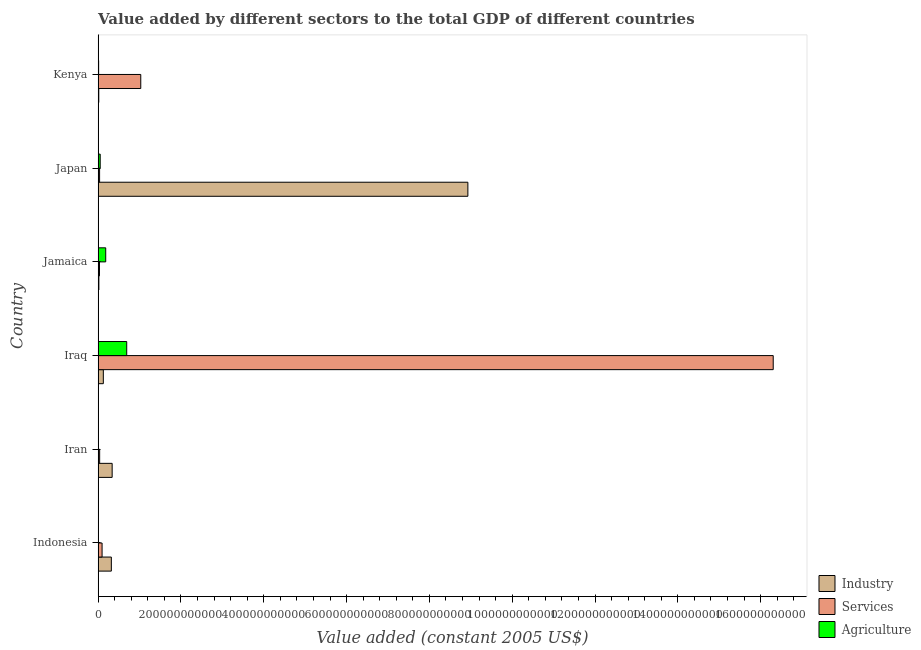How many different coloured bars are there?
Your answer should be compact. 3. Are the number of bars per tick equal to the number of legend labels?
Provide a short and direct response. Yes. How many bars are there on the 4th tick from the top?
Offer a terse response. 3. What is the label of the 2nd group of bars from the top?
Your answer should be compact. Japan. What is the value added by services in Iraq?
Your answer should be very brief. 1.63e+12. Across all countries, what is the maximum value added by services?
Make the answer very short. 1.63e+12. Across all countries, what is the minimum value added by agricultural sector?
Keep it short and to the point. 1.66e+08. In which country was the value added by services maximum?
Provide a succinct answer. Iraq. In which country was the value added by services minimum?
Your answer should be very brief. Jamaica. What is the total value added by industrial sector in the graph?
Give a very brief answer. 9.75e+11. What is the difference between the value added by agricultural sector in Indonesia and that in Jamaica?
Your answer should be very brief. -1.82e+1. What is the difference between the value added by industrial sector in Japan and the value added by agricultural sector in Iran?
Make the answer very short. 8.92e+11. What is the average value added by services per country?
Your response must be concise. 2.92e+11. What is the difference between the value added by services and value added by agricultural sector in Iran?
Your response must be concise. 3.07e+09. What is the ratio of the value added by agricultural sector in Japan to that in Kenya?
Your answer should be compact. 4.04. Is the value added by services in Iran less than that in Japan?
Offer a very short reply. No. What is the difference between the highest and the second highest value added by agricultural sector?
Offer a terse response. 5.07e+1. What is the difference between the highest and the lowest value added by services?
Provide a short and direct response. 1.63e+12. What does the 2nd bar from the top in Jamaica represents?
Provide a short and direct response. Services. What does the 1st bar from the bottom in Indonesia represents?
Keep it short and to the point. Industry. Is it the case that in every country, the sum of the value added by industrial sector and value added by services is greater than the value added by agricultural sector?
Your answer should be compact. No. How many countries are there in the graph?
Provide a succinct answer. 6. What is the difference between two consecutive major ticks on the X-axis?
Your answer should be very brief. 2.00e+11. Are the values on the major ticks of X-axis written in scientific E-notation?
Your answer should be compact. No. Does the graph contain grids?
Provide a succinct answer. No. Where does the legend appear in the graph?
Your answer should be very brief. Bottom right. How are the legend labels stacked?
Offer a very short reply. Vertical. What is the title of the graph?
Offer a very short reply. Value added by different sectors to the total GDP of different countries. What is the label or title of the X-axis?
Your answer should be very brief. Value added (constant 2005 US$). What is the Value added (constant 2005 US$) in Industry in Indonesia?
Give a very brief answer. 3.20e+1. What is the Value added (constant 2005 US$) in Services in Indonesia?
Make the answer very short. 9.55e+09. What is the Value added (constant 2005 US$) in Agriculture in Indonesia?
Your answer should be compact. 1.66e+08. What is the Value added (constant 2005 US$) of Industry in Iran?
Your answer should be compact. 3.39e+1. What is the Value added (constant 2005 US$) of Services in Iran?
Provide a short and direct response. 3.70e+09. What is the Value added (constant 2005 US$) in Agriculture in Iran?
Keep it short and to the point. 6.29e+08. What is the Value added (constant 2005 US$) in Industry in Iraq?
Your response must be concise. 1.26e+1. What is the Value added (constant 2005 US$) of Services in Iraq?
Your response must be concise. 1.63e+12. What is the Value added (constant 2005 US$) of Agriculture in Iraq?
Provide a succinct answer. 6.91e+1. What is the Value added (constant 2005 US$) of Industry in Jamaica?
Give a very brief answer. 1.84e+09. What is the Value added (constant 2005 US$) of Services in Jamaica?
Your response must be concise. 3.31e+09. What is the Value added (constant 2005 US$) in Agriculture in Jamaica?
Ensure brevity in your answer.  1.84e+1. What is the Value added (constant 2005 US$) of Industry in Japan?
Provide a succinct answer. 8.93e+11. What is the Value added (constant 2005 US$) in Services in Japan?
Keep it short and to the point. 3.56e+09. What is the Value added (constant 2005 US$) in Agriculture in Japan?
Offer a terse response. 5.04e+09. What is the Value added (constant 2005 US$) in Industry in Kenya?
Ensure brevity in your answer.  1.60e+09. What is the Value added (constant 2005 US$) of Services in Kenya?
Give a very brief answer. 1.03e+11. What is the Value added (constant 2005 US$) in Agriculture in Kenya?
Your answer should be compact. 1.25e+09. Across all countries, what is the maximum Value added (constant 2005 US$) in Industry?
Your response must be concise. 8.93e+11. Across all countries, what is the maximum Value added (constant 2005 US$) in Services?
Make the answer very short. 1.63e+12. Across all countries, what is the maximum Value added (constant 2005 US$) of Agriculture?
Offer a terse response. 6.91e+1. Across all countries, what is the minimum Value added (constant 2005 US$) of Industry?
Provide a short and direct response. 1.60e+09. Across all countries, what is the minimum Value added (constant 2005 US$) of Services?
Give a very brief answer. 3.31e+09. Across all countries, what is the minimum Value added (constant 2005 US$) in Agriculture?
Your response must be concise. 1.66e+08. What is the total Value added (constant 2005 US$) in Industry in the graph?
Your response must be concise. 9.75e+11. What is the total Value added (constant 2005 US$) in Services in the graph?
Make the answer very short. 1.75e+12. What is the total Value added (constant 2005 US$) of Agriculture in the graph?
Provide a succinct answer. 9.45e+1. What is the difference between the Value added (constant 2005 US$) of Industry in Indonesia and that in Iran?
Offer a terse response. -1.95e+09. What is the difference between the Value added (constant 2005 US$) in Services in Indonesia and that in Iran?
Make the answer very short. 5.85e+09. What is the difference between the Value added (constant 2005 US$) in Agriculture in Indonesia and that in Iran?
Make the answer very short. -4.63e+08. What is the difference between the Value added (constant 2005 US$) in Industry in Indonesia and that in Iraq?
Your answer should be very brief. 1.94e+1. What is the difference between the Value added (constant 2005 US$) of Services in Indonesia and that in Iraq?
Your answer should be very brief. -1.62e+12. What is the difference between the Value added (constant 2005 US$) in Agriculture in Indonesia and that in Iraq?
Your response must be concise. -6.89e+1. What is the difference between the Value added (constant 2005 US$) of Industry in Indonesia and that in Jamaica?
Your response must be concise. 3.01e+1. What is the difference between the Value added (constant 2005 US$) of Services in Indonesia and that in Jamaica?
Provide a succinct answer. 6.24e+09. What is the difference between the Value added (constant 2005 US$) of Agriculture in Indonesia and that in Jamaica?
Provide a short and direct response. -1.82e+1. What is the difference between the Value added (constant 2005 US$) of Industry in Indonesia and that in Japan?
Make the answer very short. -8.61e+11. What is the difference between the Value added (constant 2005 US$) of Services in Indonesia and that in Japan?
Keep it short and to the point. 5.99e+09. What is the difference between the Value added (constant 2005 US$) in Agriculture in Indonesia and that in Japan?
Keep it short and to the point. -4.87e+09. What is the difference between the Value added (constant 2005 US$) of Industry in Indonesia and that in Kenya?
Offer a very short reply. 3.04e+1. What is the difference between the Value added (constant 2005 US$) in Services in Indonesia and that in Kenya?
Keep it short and to the point. -9.34e+1. What is the difference between the Value added (constant 2005 US$) in Agriculture in Indonesia and that in Kenya?
Offer a very short reply. -1.08e+09. What is the difference between the Value added (constant 2005 US$) in Industry in Iran and that in Iraq?
Offer a terse response. 2.13e+1. What is the difference between the Value added (constant 2005 US$) in Services in Iran and that in Iraq?
Provide a succinct answer. -1.63e+12. What is the difference between the Value added (constant 2005 US$) of Agriculture in Iran and that in Iraq?
Keep it short and to the point. -6.84e+1. What is the difference between the Value added (constant 2005 US$) in Industry in Iran and that in Jamaica?
Keep it short and to the point. 3.21e+1. What is the difference between the Value added (constant 2005 US$) of Services in Iran and that in Jamaica?
Ensure brevity in your answer.  3.91e+08. What is the difference between the Value added (constant 2005 US$) of Agriculture in Iran and that in Jamaica?
Offer a very short reply. -1.77e+1. What is the difference between the Value added (constant 2005 US$) of Industry in Iran and that in Japan?
Keep it short and to the point. -8.59e+11. What is the difference between the Value added (constant 2005 US$) in Services in Iran and that in Japan?
Offer a very short reply. 1.42e+08. What is the difference between the Value added (constant 2005 US$) in Agriculture in Iran and that in Japan?
Offer a very short reply. -4.41e+09. What is the difference between the Value added (constant 2005 US$) in Industry in Iran and that in Kenya?
Give a very brief answer. 3.23e+1. What is the difference between the Value added (constant 2005 US$) in Services in Iran and that in Kenya?
Give a very brief answer. -9.93e+1. What is the difference between the Value added (constant 2005 US$) of Agriculture in Iran and that in Kenya?
Provide a short and direct response. -6.16e+08. What is the difference between the Value added (constant 2005 US$) in Industry in Iraq and that in Jamaica?
Provide a succinct answer. 1.08e+1. What is the difference between the Value added (constant 2005 US$) in Services in Iraq and that in Jamaica?
Your answer should be very brief. 1.63e+12. What is the difference between the Value added (constant 2005 US$) in Agriculture in Iraq and that in Jamaica?
Provide a short and direct response. 5.07e+1. What is the difference between the Value added (constant 2005 US$) of Industry in Iraq and that in Japan?
Provide a short and direct response. -8.80e+11. What is the difference between the Value added (constant 2005 US$) in Services in Iraq and that in Japan?
Give a very brief answer. 1.63e+12. What is the difference between the Value added (constant 2005 US$) of Agriculture in Iraq and that in Japan?
Ensure brevity in your answer.  6.40e+1. What is the difference between the Value added (constant 2005 US$) in Industry in Iraq and that in Kenya?
Offer a terse response. 1.10e+1. What is the difference between the Value added (constant 2005 US$) of Services in Iraq and that in Kenya?
Offer a terse response. 1.53e+12. What is the difference between the Value added (constant 2005 US$) in Agriculture in Iraq and that in Kenya?
Provide a short and direct response. 6.78e+1. What is the difference between the Value added (constant 2005 US$) in Industry in Jamaica and that in Japan?
Give a very brief answer. -8.91e+11. What is the difference between the Value added (constant 2005 US$) in Services in Jamaica and that in Japan?
Provide a short and direct response. -2.48e+08. What is the difference between the Value added (constant 2005 US$) of Agriculture in Jamaica and that in Japan?
Offer a terse response. 1.33e+1. What is the difference between the Value added (constant 2005 US$) in Industry in Jamaica and that in Kenya?
Ensure brevity in your answer.  2.39e+08. What is the difference between the Value added (constant 2005 US$) in Services in Jamaica and that in Kenya?
Your response must be concise. -9.97e+1. What is the difference between the Value added (constant 2005 US$) in Agriculture in Jamaica and that in Kenya?
Your answer should be compact. 1.71e+1. What is the difference between the Value added (constant 2005 US$) in Industry in Japan and that in Kenya?
Your answer should be compact. 8.91e+11. What is the difference between the Value added (constant 2005 US$) in Services in Japan and that in Kenya?
Ensure brevity in your answer.  -9.94e+1. What is the difference between the Value added (constant 2005 US$) of Agriculture in Japan and that in Kenya?
Your response must be concise. 3.79e+09. What is the difference between the Value added (constant 2005 US$) of Industry in Indonesia and the Value added (constant 2005 US$) of Services in Iran?
Ensure brevity in your answer.  2.82e+1. What is the difference between the Value added (constant 2005 US$) of Industry in Indonesia and the Value added (constant 2005 US$) of Agriculture in Iran?
Your answer should be very brief. 3.13e+1. What is the difference between the Value added (constant 2005 US$) in Services in Indonesia and the Value added (constant 2005 US$) in Agriculture in Iran?
Offer a terse response. 8.92e+09. What is the difference between the Value added (constant 2005 US$) in Industry in Indonesia and the Value added (constant 2005 US$) in Services in Iraq?
Your answer should be very brief. -1.60e+12. What is the difference between the Value added (constant 2005 US$) of Industry in Indonesia and the Value added (constant 2005 US$) of Agriculture in Iraq?
Your response must be concise. -3.71e+1. What is the difference between the Value added (constant 2005 US$) of Services in Indonesia and the Value added (constant 2005 US$) of Agriculture in Iraq?
Provide a succinct answer. -5.95e+1. What is the difference between the Value added (constant 2005 US$) in Industry in Indonesia and the Value added (constant 2005 US$) in Services in Jamaica?
Offer a terse response. 2.86e+1. What is the difference between the Value added (constant 2005 US$) of Industry in Indonesia and the Value added (constant 2005 US$) of Agriculture in Jamaica?
Your answer should be very brief. 1.36e+1. What is the difference between the Value added (constant 2005 US$) of Services in Indonesia and the Value added (constant 2005 US$) of Agriculture in Jamaica?
Offer a very short reply. -8.81e+09. What is the difference between the Value added (constant 2005 US$) in Industry in Indonesia and the Value added (constant 2005 US$) in Services in Japan?
Keep it short and to the point. 2.84e+1. What is the difference between the Value added (constant 2005 US$) of Industry in Indonesia and the Value added (constant 2005 US$) of Agriculture in Japan?
Keep it short and to the point. 2.69e+1. What is the difference between the Value added (constant 2005 US$) in Services in Indonesia and the Value added (constant 2005 US$) in Agriculture in Japan?
Keep it short and to the point. 4.52e+09. What is the difference between the Value added (constant 2005 US$) in Industry in Indonesia and the Value added (constant 2005 US$) in Services in Kenya?
Provide a short and direct response. -7.10e+1. What is the difference between the Value added (constant 2005 US$) of Industry in Indonesia and the Value added (constant 2005 US$) of Agriculture in Kenya?
Offer a terse response. 3.07e+1. What is the difference between the Value added (constant 2005 US$) in Services in Indonesia and the Value added (constant 2005 US$) in Agriculture in Kenya?
Offer a very short reply. 8.31e+09. What is the difference between the Value added (constant 2005 US$) in Industry in Iran and the Value added (constant 2005 US$) in Services in Iraq?
Your response must be concise. -1.60e+12. What is the difference between the Value added (constant 2005 US$) in Industry in Iran and the Value added (constant 2005 US$) in Agriculture in Iraq?
Give a very brief answer. -3.52e+1. What is the difference between the Value added (constant 2005 US$) of Services in Iran and the Value added (constant 2005 US$) of Agriculture in Iraq?
Make the answer very short. -6.54e+1. What is the difference between the Value added (constant 2005 US$) of Industry in Iran and the Value added (constant 2005 US$) of Services in Jamaica?
Provide a short and direct response. 3.06e+1. What is the difference between the Value added (constant 2005 US$) in Industry in Iran and the Value added (constant 2005 US$) in Agriculture in Jamaica?
Offer a very short reply. 1.55e+1. What is the difference between the Value added (constant 2005 US$) in Services in Iran and the Value added (constant 2005 US$) in Agriculture in Jamaica?
Keep it short and to the point. -1.47e+1. What is the difference between the Value added (constant 2005 US$) of Industry in Iran and the Value added (constant 2005 US$) of Services in Japan?
Your answer should be very brief. 3.03e+1. What is the difference between the Value added (constant 2005 US$) in Industry in Iran and the Value added (constant 2005 US$) in Agriculture in Japan?
Ensure brevity in your answer.  2.89e+1. What is the difference between the Value added (constant 2005 US$) of Services in Iran and the Value added (constant 2005 US$) of Agriculture in Japan?
Give a very brief answer. -1.33e+09. What is the difference between the Value added (constant 2005 US$) in Industry in Iran and the Value added (constant 2005 US$) in Services in Kenya?
Make the answer very short. -6.91e+1. What is the difference between the Value added (constant 2005 US$) in Industry in Iran and the Value added (constant 2005 US$) in Agriculture in Kenya?
Offer a terse response. 3.27e+1. What is the difference between the Value added (constant 2005 US$) in Services in Iran and the Value added (constant 2005 US$) in Agriculture in Kenya?
Your answer should be very brief. 2.46e+09. What is the difference between the Value added (constant 2005 US$) in Industry in Iraq and the Value added (constant 2005 US$) in Services in Jamaica?
Provide a succinct answer. 9.29e+09. What is the difference between the Value added (constant 2005 US$) of Industry in Iraq and the Value added (constant 2005 US$) of Agriculture in Jamaica?
Give a very brief answer. -5.76e+09. What is the difference between the Value added (constant 2005 US$) of Services in Iraq and the Value added (constant 2005 US$) of Agriculture in Jamaica?
Your answer should be compact. 1.61e+12. What is the difference between the Value added (constant 2005 US$) in Industry in Iraq and the Value added (constant 2005 US$) in Services in Japan?
Make the answer very short. 9.04e+09. What is the difference between the Value added (constant 2005 US$) of Industry in Iraq and the Value added (constant 2005 US$) of Agriculture in Japan?
Make the answer very short. 7.56e+09. What is the difference between the Value added (constant 2005 US$) in Services in Iraq and the Value added (constant 2005 US$) in Agriculture in Japan?
Make the answer very short. 1.63e+12. What is the difference between the Value added (constant 2005 US$) of Industry in Iraq and the Value added (constant 2005 US$) of Services in Kenya?
Your answer should be very brief. -9.04e+1. What is the difference between the Value added (constant 2005 US$) in Industry in Iraq and the Value added (constant 2005 US$) in Agriculture in Kenya?
Give a very brief answer. 1.14e+1. What is the difference between the Value added (constant 2005 US$) of Services in Iraq and the Value added (constant 2005 US$) of Agriculture in Kenya?
Keep it short and to the point. 1.63e+12. What is the difference between the Value added (constant 2005 US$) in Industry in Jamaica and the Value added (constant 2005 US$) in Services in Japan?
Your response must be concise. -1.72e+09. What is the difference between the Value added (constant 2005 US$) of Industry in Jamaica and the Value added (constant 2005 US$) of Agriculture in Japan?
Provide a succinct answer. -3.20e+09. What is the difference between the Value added (constant 2005 US$) of Services in Jamaica and the Value added (constant 2005 US$) of Agriculture in Japan?
Make the answer very short. -1.72e+09. What is the difference between the Value added (constant 2005 US$) in Industry in Jamaica and the Value added (constant 2005 US$) in Services in Kenya?
Your response must be concise. -1.01e+11. What is the difference between the Value added (constant 2005 US$) in Industry in Jamaica and the Value added (constant 2005 US$) in Agriculture in Kenya?
Make the answer very short. 5.90e+08. What is the difference between the Value added (constant 2005 US$) of Services in Jamaica and the Value added (constant 2005 US$) of Agriculture in Kenya?
Make the answer very short. 2.07e+09. What is the difference between the Value added (constant 2005 US$) in Industry in Japan and the Value added (constant 2005 US$) in Services in Kenya?
Ensure brevity in your answer.  7.90e+11. What is the difference between the Value added (constant 2005 US$) of Industry in Japan and the Value added (constant 2005 US$) of Agriculture in Kenya?
Ensure brevity in your answer.  8.92e+11. What is the difference between the Value added (constant 2005 US$) in Services in Japan and the Value added (constant 2005 US$) in Agriculture in Kenya?
Your answer should be compact. 2.31e+09. What is the average Value added (constant 2005 US$) of Industry per country?
Make the answer very short. 1.62e+11. What is the average Value added (constant 2005 US$) of Services per country?
Offer a very short reply. 2.92e+11. What is the average Value added (constant 2005 US$) of Agriculture per country?
Your answer should be compact. 1.58e+1. What is the difference between the Value added (constant 2005 US$) of Industry and Value added (constant 2005 US$) of Services in Indonesia?
Make the answer very short. 2.24e+1. What is the difference between the Value added (constant 2005 US$) of Industry and Value added (constant 2005 US$) of Agriculture in Indonesia?
Make the answer very short. 3.18e+1. What is the difference between the Value added (constant 2005 US$) of Services and Value added (constant 2005 US$) of Agriculture in Indonesia?
Provide a succinct answer. 9.39e+09. What is the difference between the Value added (constant 2005 US$) of Industry and Value added (constant 2005 US$) of Services in Iran?
Offer a terse response. 3.02e+1. What is the difference between the Value added (constant 2005 US$) in Industry and Value added (constant 2005 US$) in Agriculture in Iran?
Provide a short and direct response. 3.33e+1. What is the difference between the Value added (constant 2005 US$) in Services and Value added (constant 2005 US$) in Agriculture in Iran?
Your answer should be very brief. 3.07e+09. What is the difference between the Value added (constant 2005 US$) in Industry and Value added (constant 2005 US$) in Services in Iraq?
Ensure brevity in your answer.  -1.62e+12. What is the difference between the Value added (constant 2005 US$) in Industry and Value added (constant 2005 US$) in Agriculture in Iraq?
Your answer should be very brief. -5.65e+1. What is the difference between the Value added (constant 2005 US$) of Services and Value added (constant 2005 US$) of Agriculture in Iraq?
Your response must be concise. 1.56e+12. What is the difference between the Value added (constant 2005 US$) in Industry and Value added (constant 2005 US$) in Services in Jamaica?
Offer a very short reply. -1.48e+09. What is the difference between the Value added (constant 2005 US$) of Industry and Value added (constant 2005 US$) of Agriculture in Jamaica?
Make the answer very short. -1.65e+1. What is the difference between the Value added (constant 2005 US$) of Services and Value added (constant 2005 US$) of Agriculture in Jamaica?
Offer a terse response. -1.51e+1. What is the difference between the Value added (constant 2005 US$) in Industry and Value added (constant 2005 US$) in Services in Japan?
Your answer should be very brief. 8.89e+11. What is the difference between the Value added (constant 2005 US$) in Industry and Value added (constant 2005 US$) in Agriculture in Japan?
Provide a succinct answer. 8.88e+11. What is the difference between the Value added (constant 2005 US$) in Services and Value added (constant 2005 US$) in Agriculture in Japan?
Your response must be concise. -1.47e+09. What is the difference between the Value added (constant 2005 US$) of Industry and Value added (constant 2005 US$) of Services in Kenya?
Your answer should be very brief. -1.01e+11. What is the difference between the Value added (constant 2005 US$) of Industry and Value added (constant 2005 US$) of Agriculture in Kenya?
Ensure brevity in your answer.  3.51e+08. What is the difference between the Value added (constant 2005 US$) of Services and Value added (constant 2005 US$) of Agriculture in Kenya?
Make the answer very short. 1.02e+11. What is the ratio of the Value added (constant 2005 US$) in Industry in Indonesia to that in Iran?
Your answer should be very brief. 0.94. What is the ratio of the Value added (constant 2005 US$) of Services in Indonesia to that in Iran?
Your response must be concise. 2.58. What is the ratio of the Value added (constant 2005 US$) in Agriculture in Indonesia to that in Iran?
Give a very brief answer. 0.26. What is the ratio of the Value added (constant 2005 US$) in Industry in Indonesia to that in Iraq?
Make the answer very short. 2.54. What is the ratio of the Value added (constant 2005 US$) of Services in Indonesia to that in Iraq?
Your response must be concise. 0.01. What is the ratio of the Value added (constant 2005 US$) in Agriculture in Indonesia to that in Iraq?
Provide a short and direct response. 0. What is the ratio of the Value added (constant 2005 US$) of Industry in Indonesia to that in Jamaica?
Offer a very short reply. 17.4. What is the ratio of the Value added (constant 2005 US$) of Services in Indonesia to that in Jamaica?
Make the answer very short. 2.88. What is the ratio of the Value added (constant 2005 US$) of Agriculture in Indonesia to that in Jamaica?
Keep it short and to the point. 0.01. What is the ratio of the Value added (constant 2005 US$) of Industry in Indonesia to that in Japan?
Your answer should be very brief. 0.04. What is the ratio of the Value added (constant 2005 US$) in Services in Indonesia to that in Japan?
Ensure brevity in your answer.  2.68. What is the ratio of the Value added (constant 2005 US$) in Agriculture in Indonesia to that in Japan?
Keep it short and to the point. 0.03. What is the ratio of the Value added (constant 2005 US$) of Industry in Indonesia to that in Kenya?
Make the answer very short. 20.01. What is the ratio of the Value added (constant 2005 US$) in Services in Indonesia to that in Kenya?
Make the answer very short. 0.09. What is the ratio of the Value added (constant 2005 US$) in Agriculture in Indonesia to that in Kenya?
Offer a terse response. 0.13. What is the ratio of the Value added (constant 2005 US$) in Industry in Iran to that in Iraq?
Give a very brief answer. 2.69. What is the ratio of the Value added (constant 2005 US$) of Services in Iran to that in Iraq?
Provide a succinct answer. 0. What is the ratio of the Value added (constant 2005 US$) of Agriculture in Iran to that in Iraq?
Offer a terse response. 0.01. What is the ratio of the Value added (constant 2005 US$) in Industry in Iran to that in Jamaica?
Provide a short and direct response. 18.47. What is the ratio of the Value added (constant 2005 US$) of Services in Iran to that in Jamaica?
Keep it short and to the point. 1.12. What is the ratio of the Value added (constant 2005 US$) in Agriculture in Iran to that in Jamaica?
Ensure brevity in your answer.  0.03. What is the ratio of the Value added (constant 2005 US$) in Industry in Iran to that in Japan?
Give a very brief answer. 0.04. What is the ratio of the Value added (constant 2005 US$) in Services in Iran to that in Japan?
Provide a short and direct response. 1.04. What is the ratio of the Value added (constant 2005 US$) in Agriculture in Iran to that in Japan?
Provide a short and direct response. 0.12. What is the ratio of the Value added (constant 2005 US$) of Industry in Iran to that in Kenya?
Keep it short and to the point. 21.23. What is the ratio of the Value added (constant 2005 US$) of Services in Iran to that in Kenya?
Your response must be concise. 0.04. What is the ratio of the Value added (constant 2005 US$) in Agriculture in Iran to that in Kenya?
Your response must be concise. 0.51. What is the ratio of the Value added (constant 2005 US$) of Industry in Iraq to that in Jamaica?
Keep it short and to the point. 6.86. What is the ratio of the Value added (constant 2005 US$) of Services in Iraq to that in Jamaica?
Your answer should be compact. 492.26. What is the ratio of the Value added (constant 2005 US$) in Agriculture in Iraq to that in Jamaica?
Your answer should be very brief. 3.76. What is the ratio of the Value added (constant 2005 US$) of Industry in Iraq to that in Japan?
Provide a short and direct response. 0.01. What is the ratio of the Value added (constant 2005 US$) of Services in Iraq to that in Japan?
Your answer should be compact. 457.93. What is the ratio of the Value added (constant 2005 US$) of Agriculture in Iraq to that in Japan?
Provide a succinct answer. 13.72. What is the ratio of the Value added (constant 2005 US$) of Industry in Iraq to that in Kenya?
Your answer should be compact. 7.89. What is the ratio of the Value added (constant 2005 US$) of Services in Iraq to that in Kenya?
Ensure brevity in your answer.  15.83. What is the ratio of the Value added (constant 2005 US$) in Agriculture in Iraq to that in Kenya?
Keep it short and to the point. 55.45. What is the ratio of the Value added (constant 2005 US$) of Industry in Jamaica to that in Japan?
Offer a terse response. 0. What is the ratio of the Value added (constant 2005 US$) in Services in Jamaica to that in Japan?
Give a very brief answer. 0.93. What is the ratio of the Value added (constant 2005 US$) in Agriculture in Jamaica to that in Japan?
Give a very brief answer. 3.65. What is the ratio of the Value added (constant 2005 US$) in Industry in Jamaica to that in Kenya?
Your answer should be compact. 1.15. What is the ratio of the Value added (constant 2005 US$) in Services in Jamaica to that in Kenya?
Provide a succinct answer. 0.03. What is the ratio of the Value added (constant 2005 US$) in Agriculture in Jamaica to that in Kenya?
Your response must be concise. 14.74. What is the ratio of the Value added (constant 2005 US$) of Industry in Japan to that in Kenya?
Provide a short and direct response. 559.25. What is the ratio of the Value added (constant 2005 US$) of Services in Japan to that in Kenya?
Ensure brevity in your answer.  0.03. What is the ratio of the Value added (constant 2005 US$) in Agriculture in Japan to that in Kenya?
Make the answer very short. 4.04. What is the difference between the highest and the second highest Value added (constant 2005 US$) of Industry?
Offer a very short reply. 8.59e+11. What is the difference between the highest and the second highest Value added (constant 2005 US$) of Services?
Provide a succinct answer. 1.53e+12. What is the difference between the highest and the second highest Value added (constant 2005 US$) of Agriculture?
Give a very brief answer. 5.07e+1. What is the difference between the highest and the lowest Value added (constant 2005 US$) in Industry?
Offer a very short reply. 8.91e+11. What is the difference between the highest and the lowest Value added (constant 2005 US$) in Services?
Your response must be concise. 1.63e+12. What is the difference between the highest and the lowest Value added (constant 2005 US$) in Agriculture?
Your answer should be very brief. 6.89e+1. 